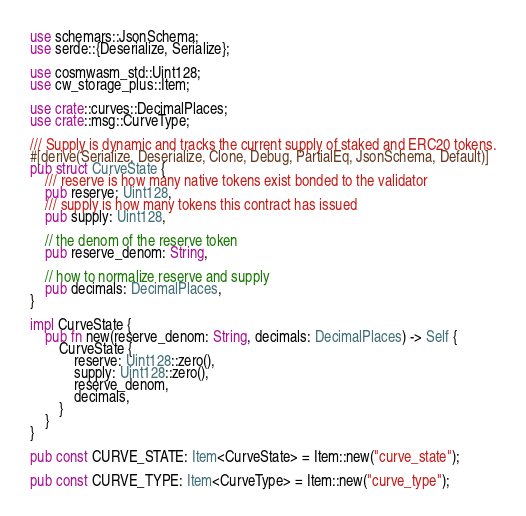Convert code to text. <code><loc_0><loc_0><loc_500><loc_500><_Rust_>use schemars::JsonSchema;
use serde::{Deserialize, Serialize};

use cosmwasm_std::Uint128;
use cw_storage_plus::Item;

use crate::curves::DecimalPlaces;
use crate::msg::CurveType;

/// Supply is dynamic and tracks the current supply of staked and ERC20 tokens.
#[derive(Serialize, Deserialize, Clone, Debug, PartialEq, JsonSchema, Default)]
pub struct CurveState {
    /// reserve is how many native tokens exist bonded to the validator
    pub reserve: Uint128,
    /// supply is how many tokens this contract has issued
    pub supply: Uint128,

    // the denom of the reserve token
    pub reserve_denom: String,

    // how to normalize reserve and supply
    pub decimals: DecimalPlaces,
}

impl CurveState {
    pub fn new(reserve_denom: String, decimals: DecimalPlaces) -> Self {
        CurveState {
            reserve: Uint128::zero(),
            supply: Uint128::zero(),
            reserve_denom,
            decimals,
        }
    }
}

pub const CURVE_STATE: Item<CurveState> = Item::new("curve_state");

pub const CURVE_TYPE: Item<CurveType> = Item::new("curve_type");
</code> 